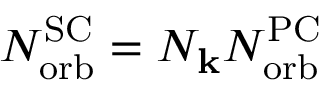Convert formula to latex. <formula><loc_0><loc_0><loc_500><loc_500>N _ { o r b } ^ { S C } = N _ { k } N _ { o r b } ^ { P C }</formula> 